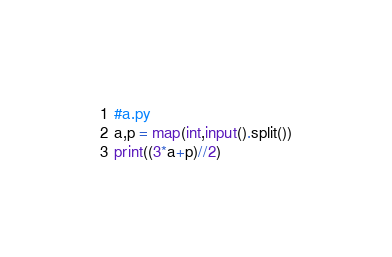<code> <loc_0><loc_0><loc_500><loc_500><_Python_>#a.py
a,p = map(int,input().split())
print((3*a+p)//2)
</code> 